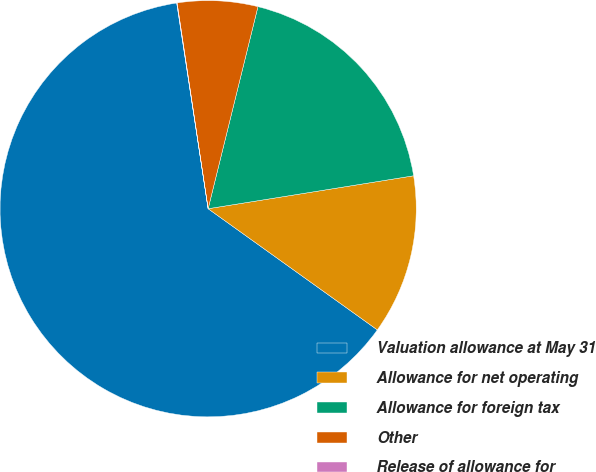Convert chart to OTSL. <chart><loc_0><loc_0><loc_500><loc_500><pie_chart><fcel>Valuation allowance at May 31<fcel>Allowance for net operating<fcel>Allowance for foreign tax<fcel>Other<fcel>Release of allowance for<nl><fcel>62.69%<fcel>12.42%<fcel>18.62%<fcel>6.23%<fcel>0.03%<nl></chart> 